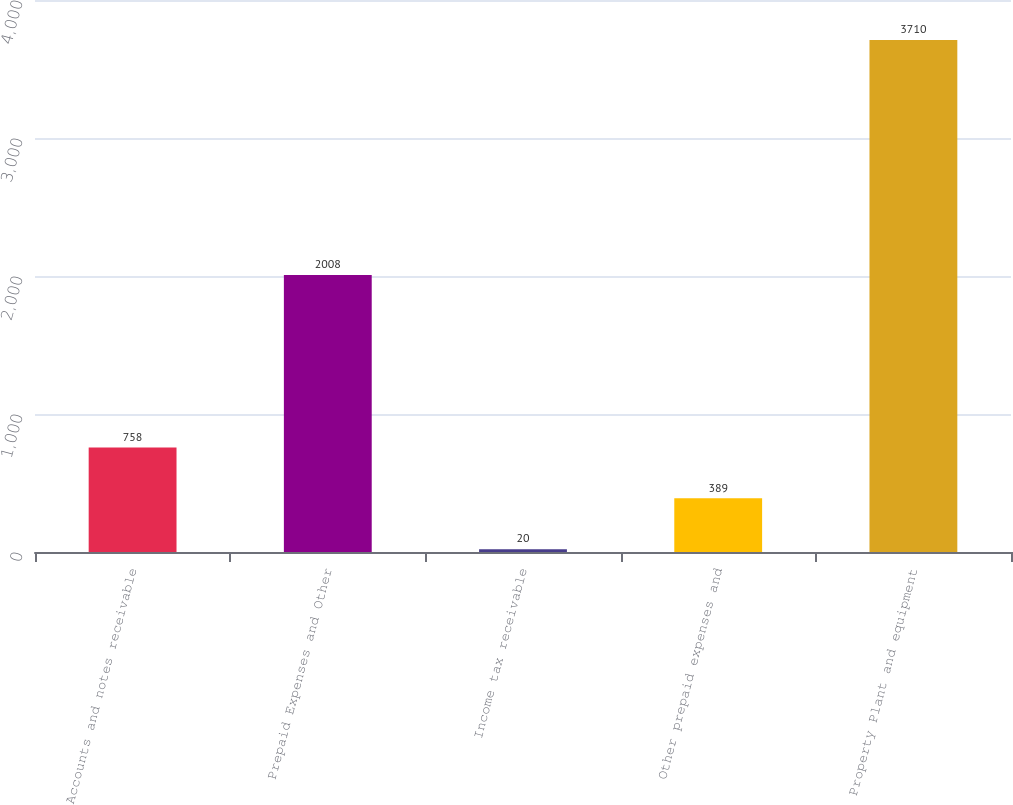Convert chart to OTSL. <chart><loc_0><loc_0><loc_500><loc_500><bar_chart><fcel>Accounts and notes receivable<fcel>Prepaid Expenses and Other<fcel>Income tax receivable<fcel>Other prepaid expenses and<fcel>Property Plant and equipment<nl><fcel>758<fcel>2008<fcel>20<fcel>389<fcel>3710<nl></chart> 